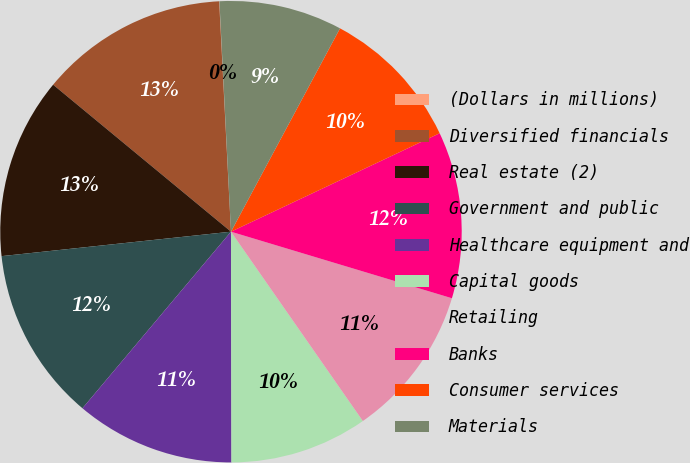Convert chart to OTSL. <chart><loc_0><loc_0><loc_500><loc_500><pie_chart><fcel>(Dollars in millions)<fcel>Diversified financials<fcel>Real estate (2)<fcel>Government and public<fcel>Healthcare equipment and<fcel>Capital goods<fcel>Retailing<fcel>Banks<fcel>Consumer services<fcel>Materials<nl><fcel>0.02%<fcel>13.19%<fcel>12.68%<fcel>12.18%<fcel>11.16%<fcel>9.65%<fcel>10.66%<fcel>11.67%<fcel>10.15%<fcel>8.63%<nl></chart> 